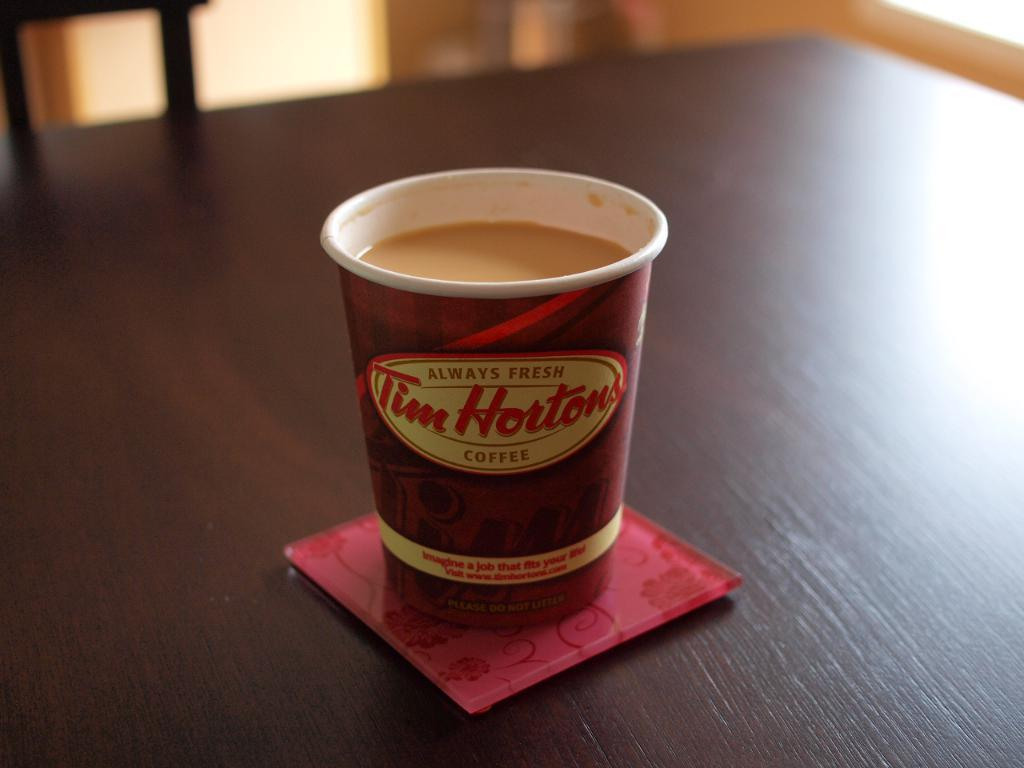What type of furniture is present in the image? There is a table in the image. What is the color of the table? The table is brown in color. What is on the table in the image? There is a glass containing coffee on the table. How many girls are sitting at the table in the image? There are no girls present in the image; it only shows a brown table with a glass of coffee on it. What type of metal is the table made of in the image? The table is not made of metal; it is made of a material that appears to be wood or a similar substance. 